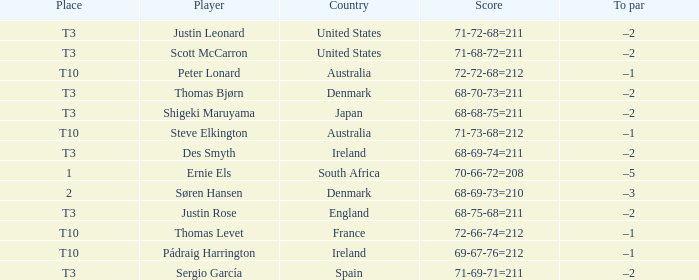What player scored 71-69-71=211? Sergio García. 